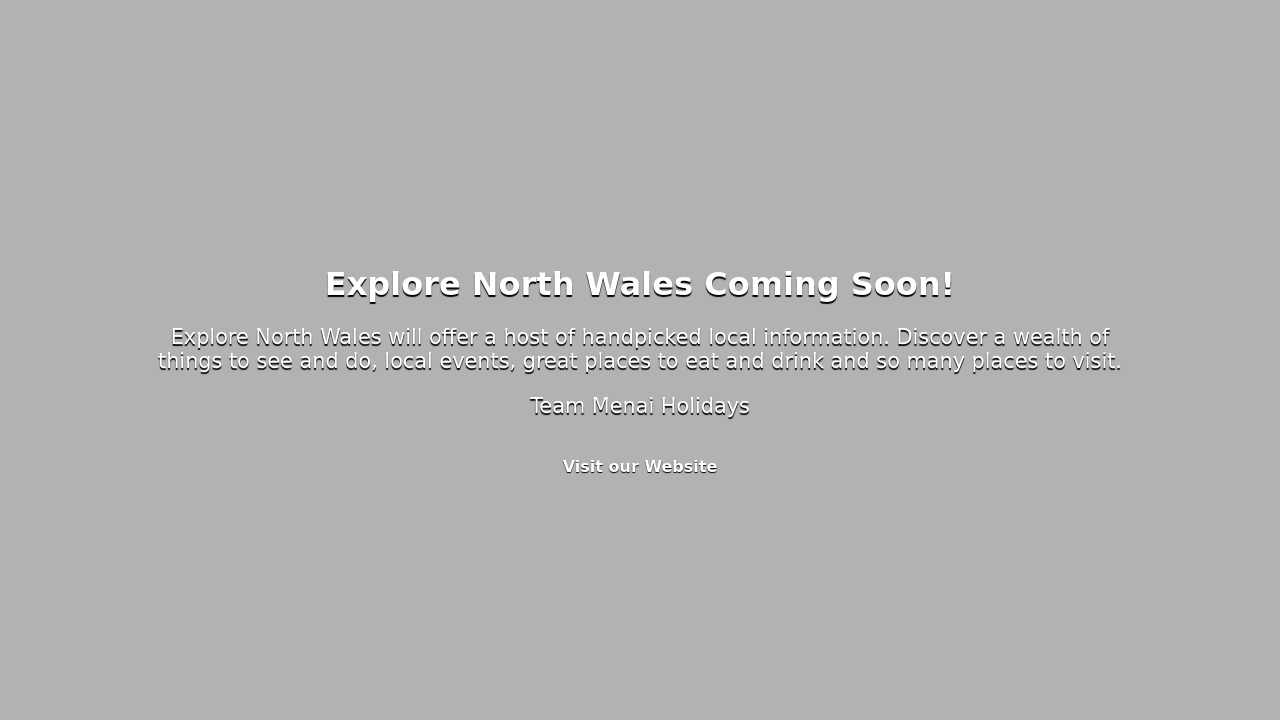Can you give me some tips for making a 'coming soon' page more engaging? Certainly! For a 'coming soon' page, consider including an attention-grabbing headline and a concise description of what's coming. Use high-quality visuals or animations related to the upcoming content to create excitement. Adding a countdown timer can build anticipation. Providing a way to subscribe for updates keeps visitors involved, and social media links encourage sharing. Finally, ensure your call to action is prominent, inviting visitors to learn more or stay connected. 